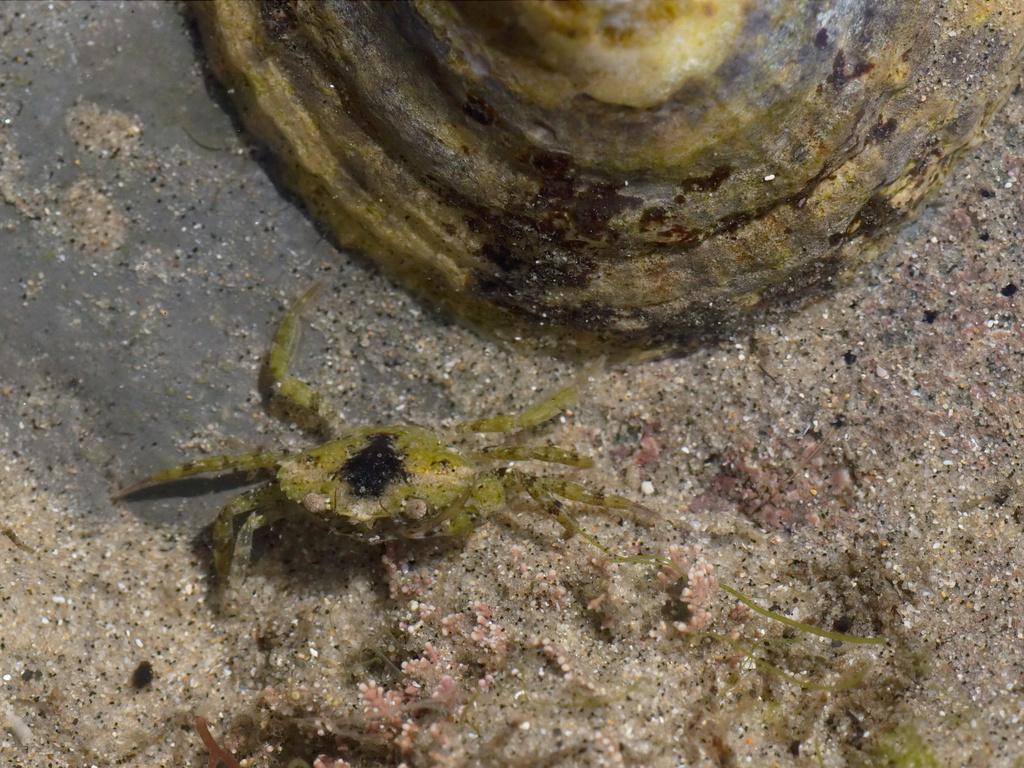How would you summarize this image in a sentence or two? In this image in front there are crabs on the sand. Behind the crabs there is some object. 